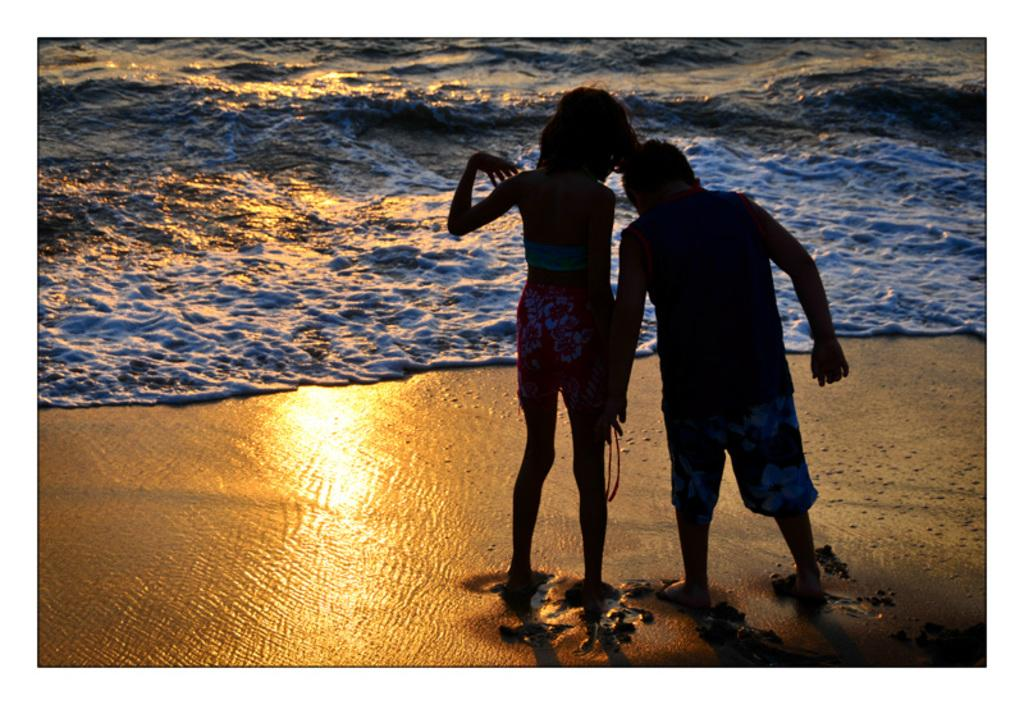What type of natural environment is depicted in the image? There is a sea in the image. Who is present in the image? There is a boy and a girl in the image. Can you describe the light focus visible at the bottom of the image? A light focus is visible at the bottom of the image. How many ants can be seen crawling on the cracker in the image? There are no ants or crackers present in the image. What is the girl doing with her head in the image? There is no indication of the girl doing anything with her head in the image. 